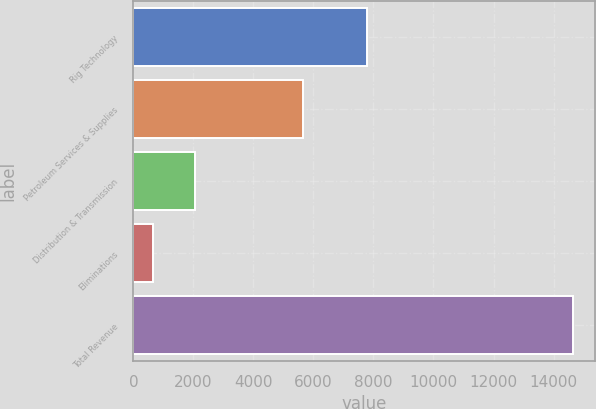<chart> <loc_0><loc_0><loc_500><loc_500><bar_chart><fcel>Rig Technology<fcel>Petroleum Services & Supplies<fcel>Distribution & Transmission<fcel>Eliminations<fcel>Total Revenue<nl><fcel>7788<fcel>5654<fcel>2057.1<fcel>657<fcel>14658<nl></chart> 